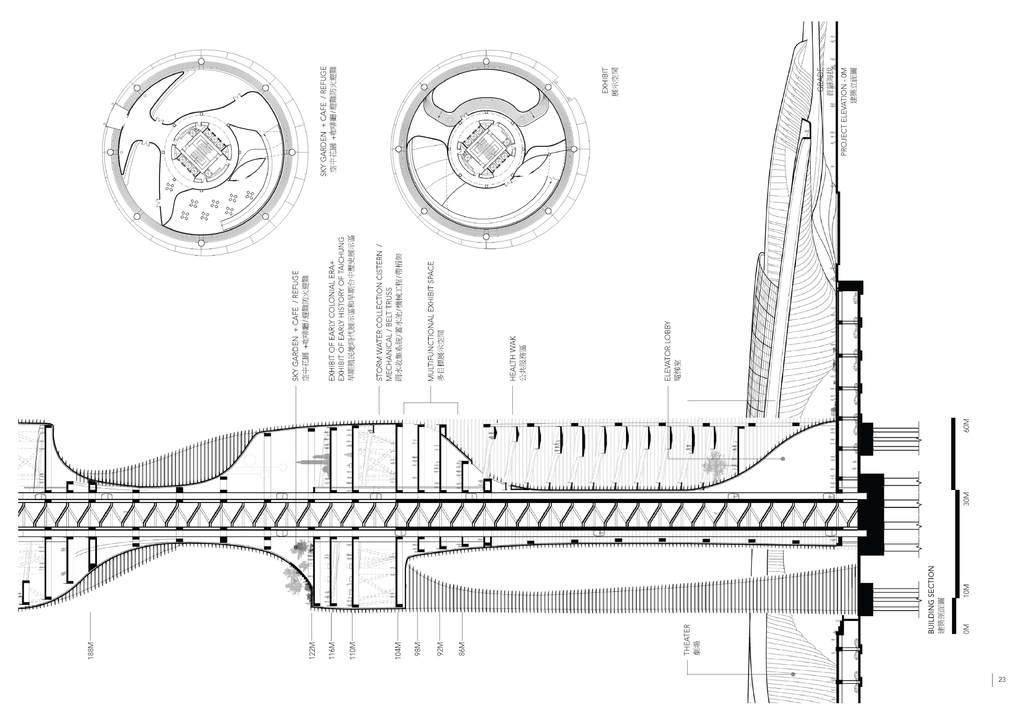How would you summarize this image in a sentence or two? This image contains some drawings and some text on it. 